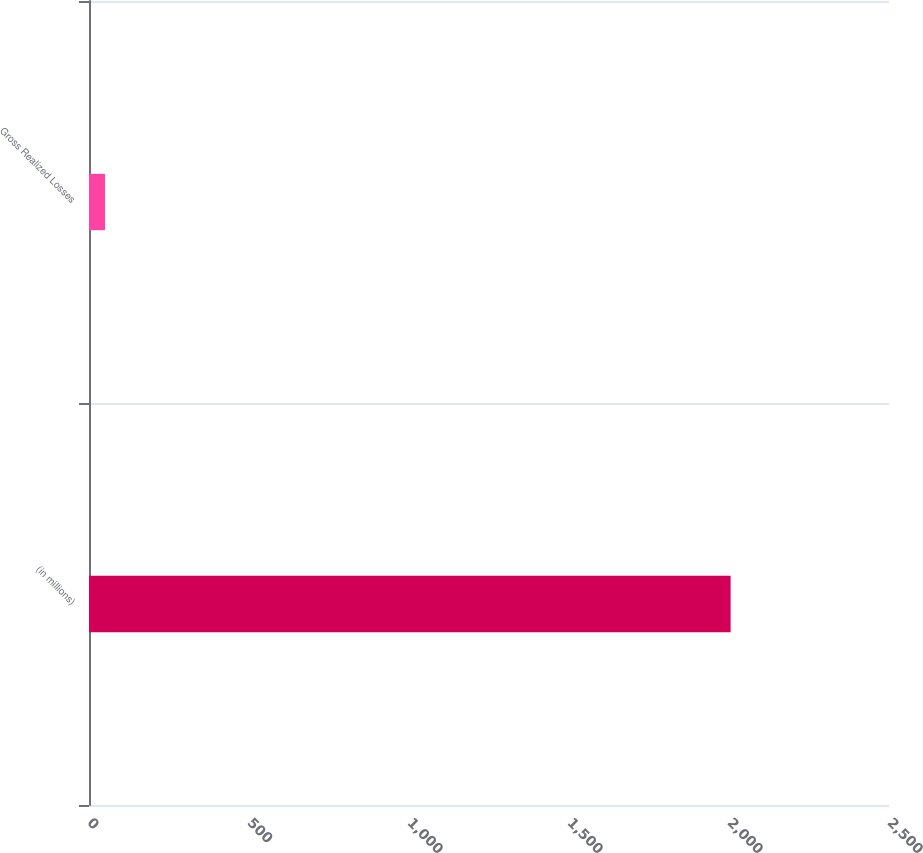Convert chart. <chart><loc_0><loc_0><loc_500><loc_500><bar_chart><fcel>(in millions)<fcel>Gross Realized Losses<nl><fcel>2005<fcel>50<nl></chart> 